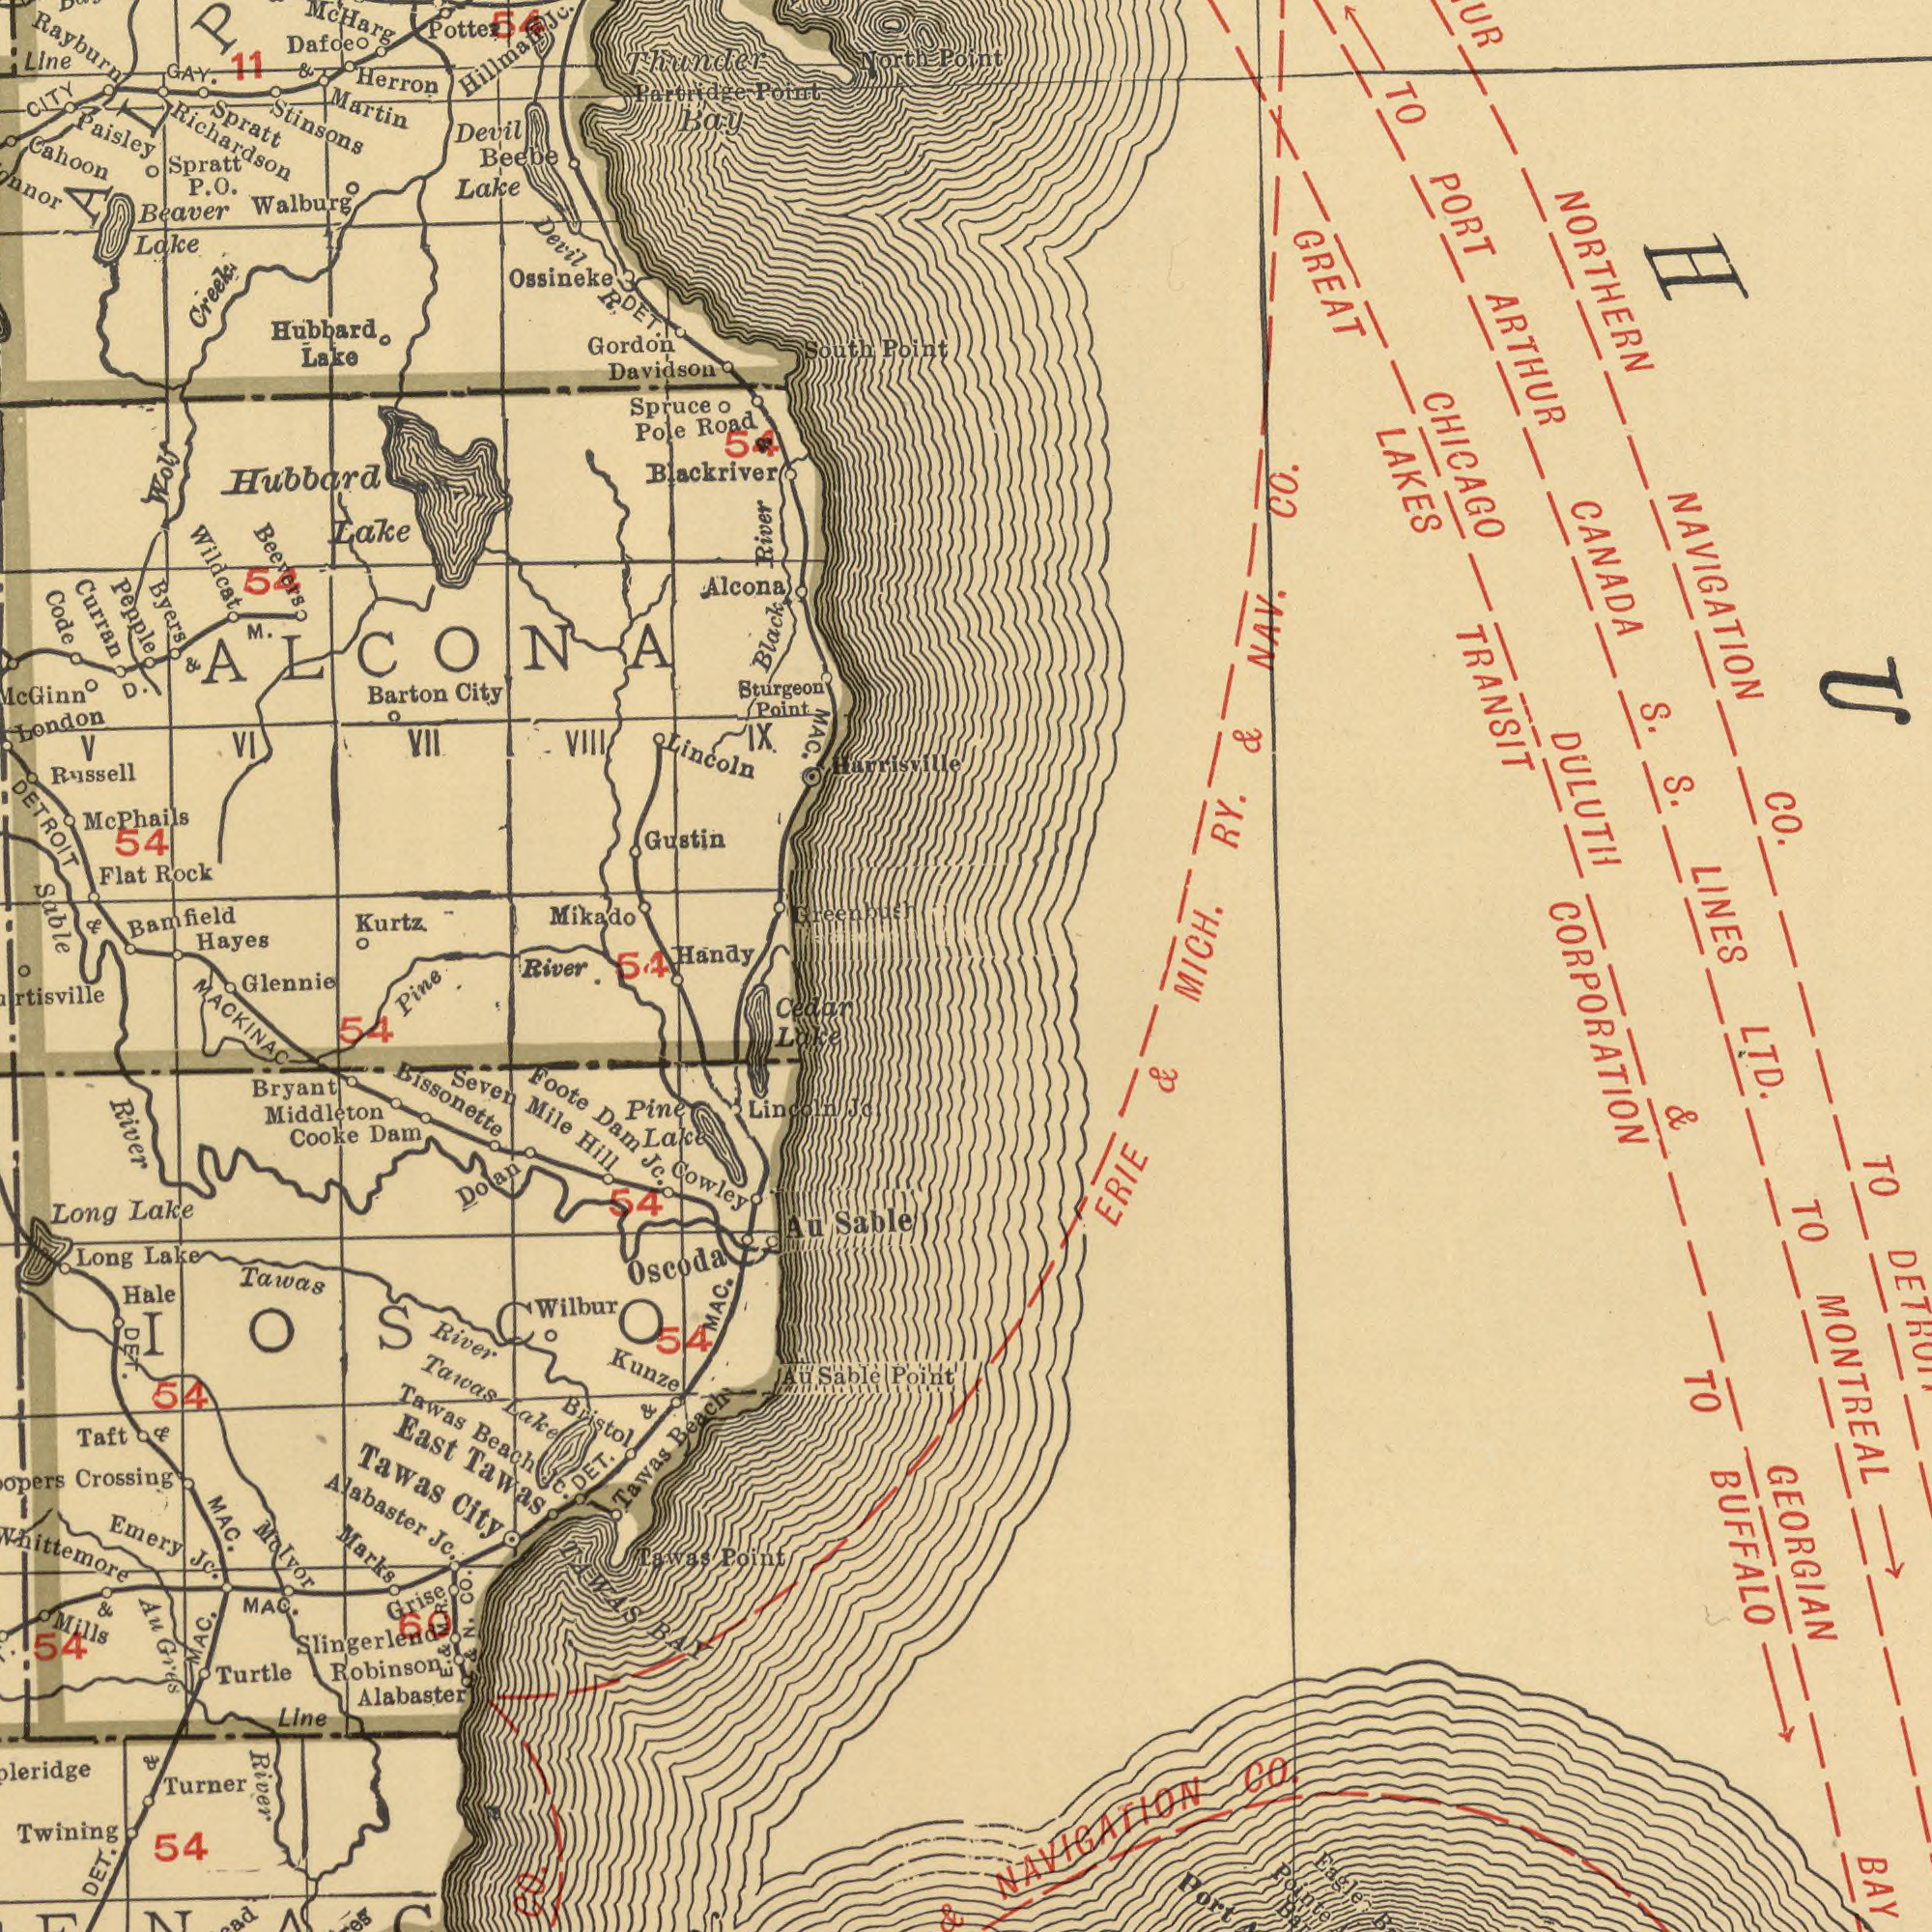What text is visible in the lower-left corner? Whittemore Tawas Middleton Crossing BAY MACKINAC River Turner Beach Twining Glennie Bristol River Au River Cowley Alabaster Foote Point Lincoln Doan Hale Robinson Long East Tawas Molvor Cooke Sable Turtle Wilbur Cedar Marks Slingerlend Au Tawas Kunze Alabaster DET. Line Lake Jc. Bryant TAWAS Seven MAC. Pine Pine Taft City Oscoda Jc. Emery MAC. Tawas Dam Point Mills Grise Jc. Jc. Lake 54 Beach Hill 54 Mile Long 54 MAC. Sable Lake Lake Tawas DED.. & Au Tawas Tawas & Gres 54 Lake N. & JC. 54 River. DET. Dam Bissonette IOSCO 54 MAC. Co. & & 60 E. & M. R. ###. CO. P What text is shown in the top-left quadrant? Stinsons Harrisville Curran DETROIT Sable Beevers Russell Beaver Richardson Paisley Hayes Ossineke Hubbard Cahoon Bamfield Wildcat Gustin Byers Kurtz Barton Flat Gordon Herron Lake Martin Road London Alcona Pepple Code Lake Bay Sturgeon Rayburn Lake Mikado City Lake Spruce South Handy Partridge Beebe Davidson Lincoln Pole Hubbard River Rock Blackriver Creek Devil Thunder IX. VIII Dafoe CITY Devil Point Point North MAC. 11 VII Spratt Hillmafi Greenbush Walburg GAY. Point V Line Spratt M. & VI DET. Black Wolf 54 Jc. & 54 R 54 54 D. & 54 ALCONA Mc Harg O. P. Mc Phails Mc Ginn & What text can you see in the bottom-right section? CORPORATION GEORGIAN BUFFALO LTD. NAVIGATION BAY CO. TO MONTREAL Eagle Port TO ERIE TO Pointe & & What text is shown in the top-right quadrant? Point NORTHERN CHICAGO CANADA GREAT CO. S. LAKES TRANSIT CO. PORT LINES MICH. DULUTH TO ARTHUR RY. & NAV. NAVIGATION S. 